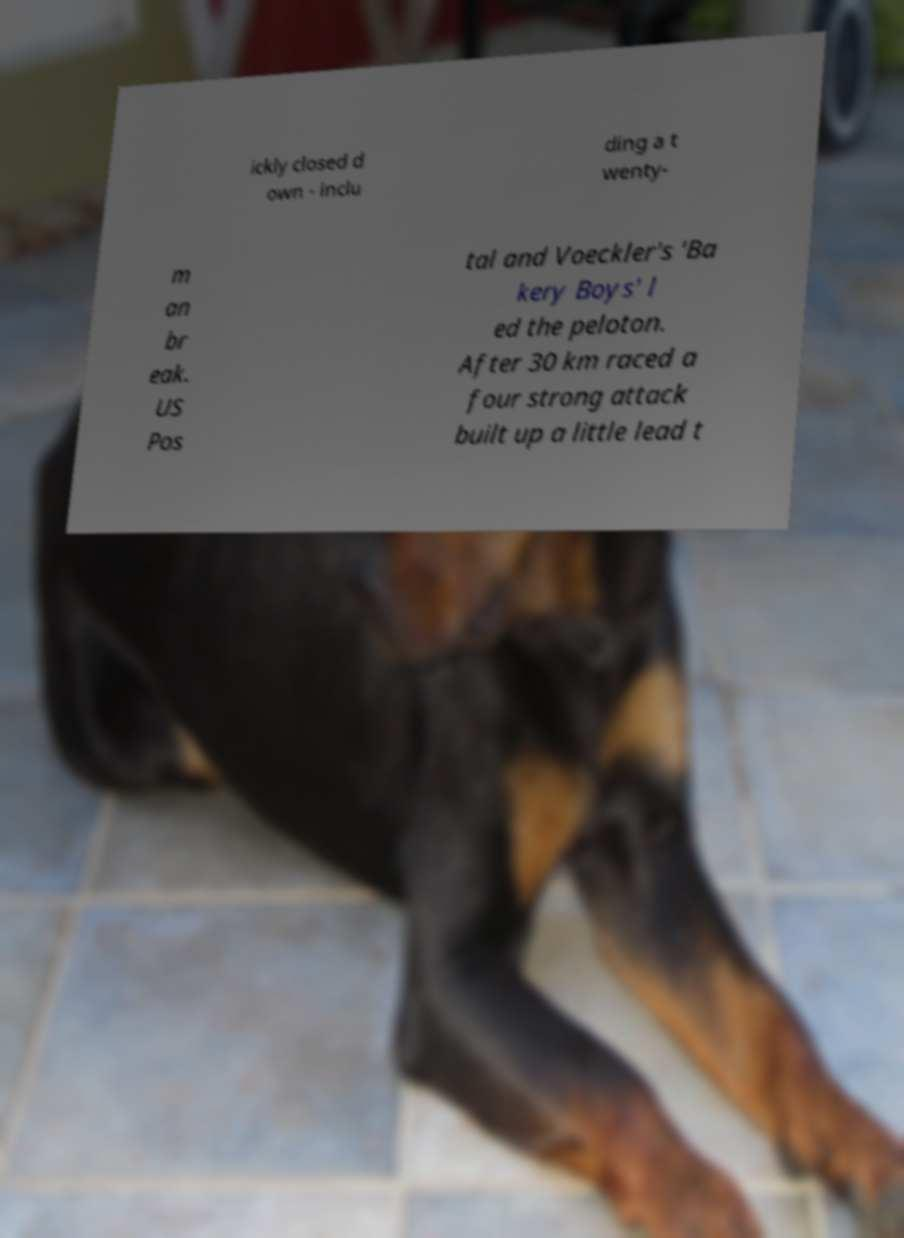Could you assist in decoding the text presented in this image and type it out clearly? ickly closed d own - inclu ding a t wenty- m an br eak. US Pos tal and Voeckler's 'Ba kery Boys' l ed the peloton. After 30 km raced a four strong attack built up a little lead t 